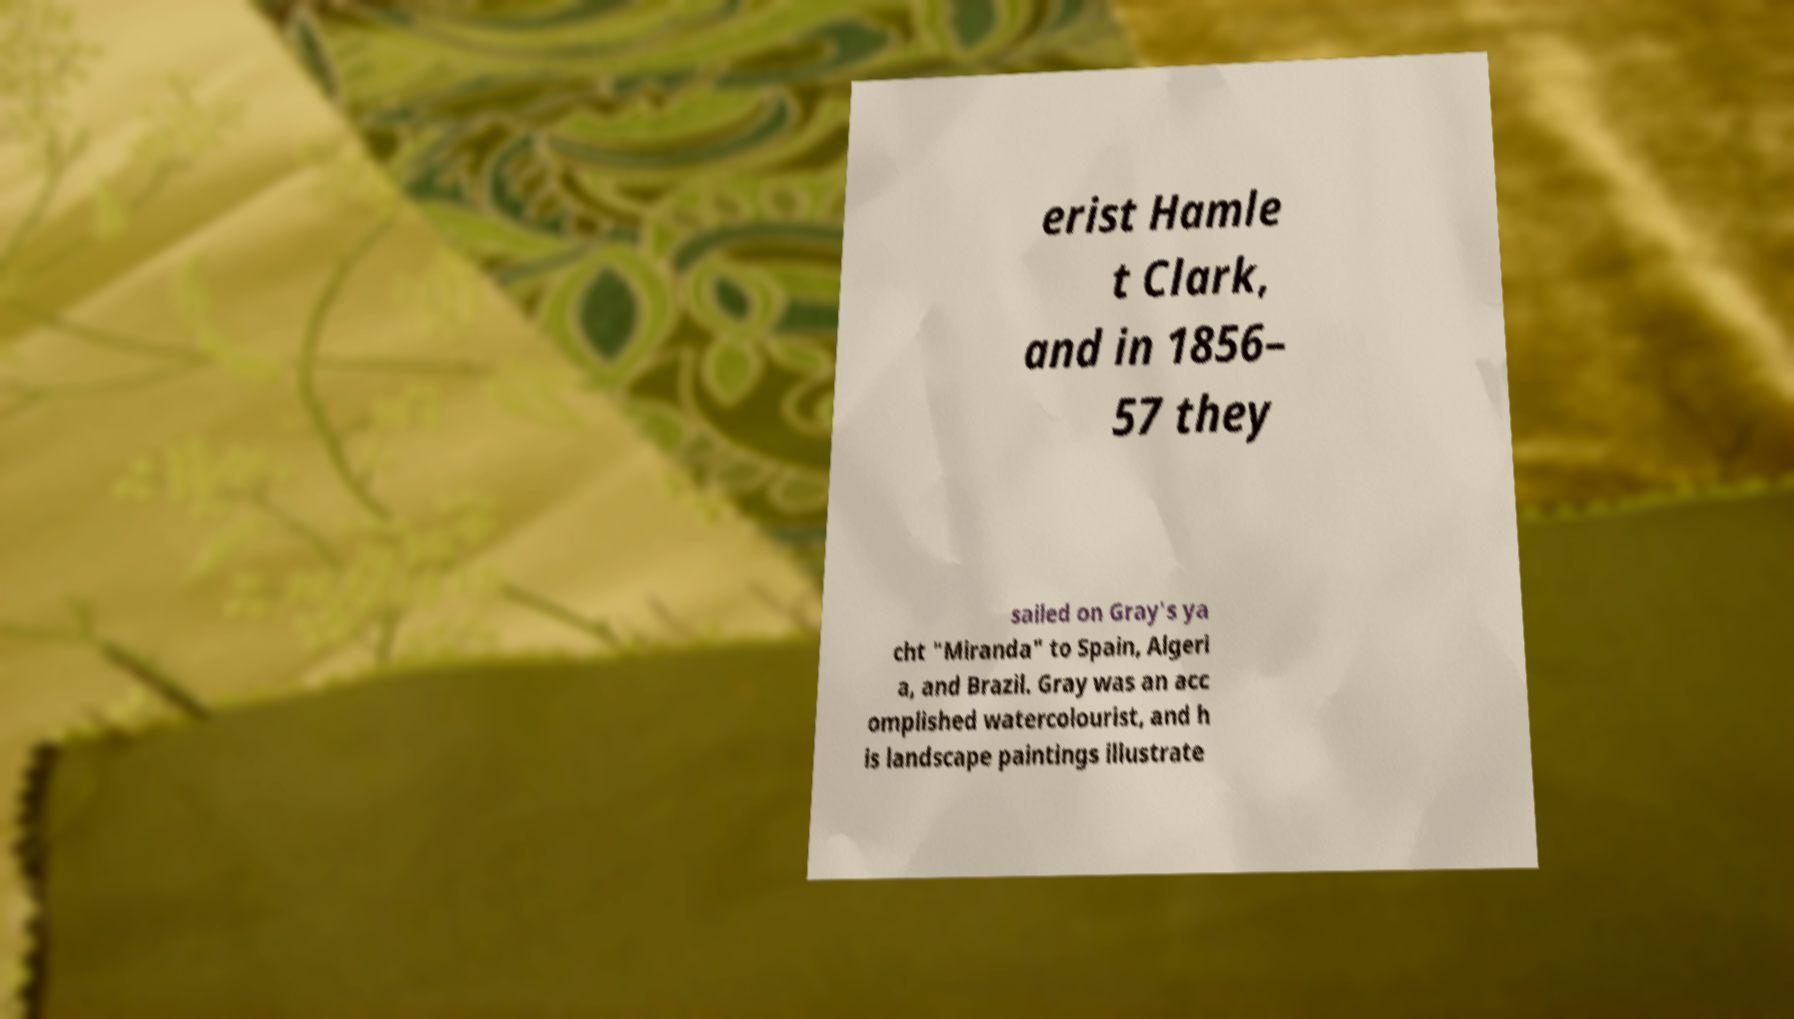Could you extract and type out the text from this image? erist Hamle t Clark, and in 1856– 57 they sailed on Gray's ya cht "Miranda" to Spain, Algeri a, and Brazil. Gray was an acc omplished watercolourist, and h is landscape paintings illustrate 